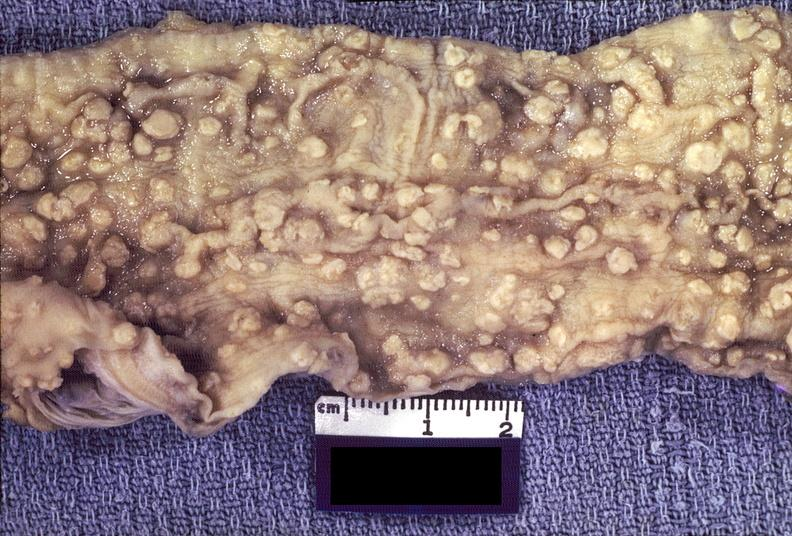what does this image show?
Answer the question using a single word or phrase. Colon 